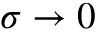Convert formula to latex. <formula><loc_0><loc_0><loc_500><loc_500>\sigma \to 0</formula> 